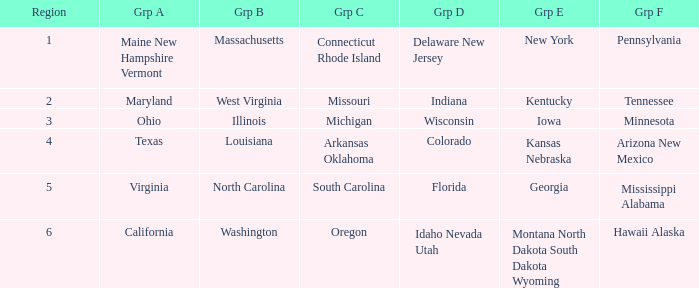What is the group A region with a region number of 2? Maryland. 